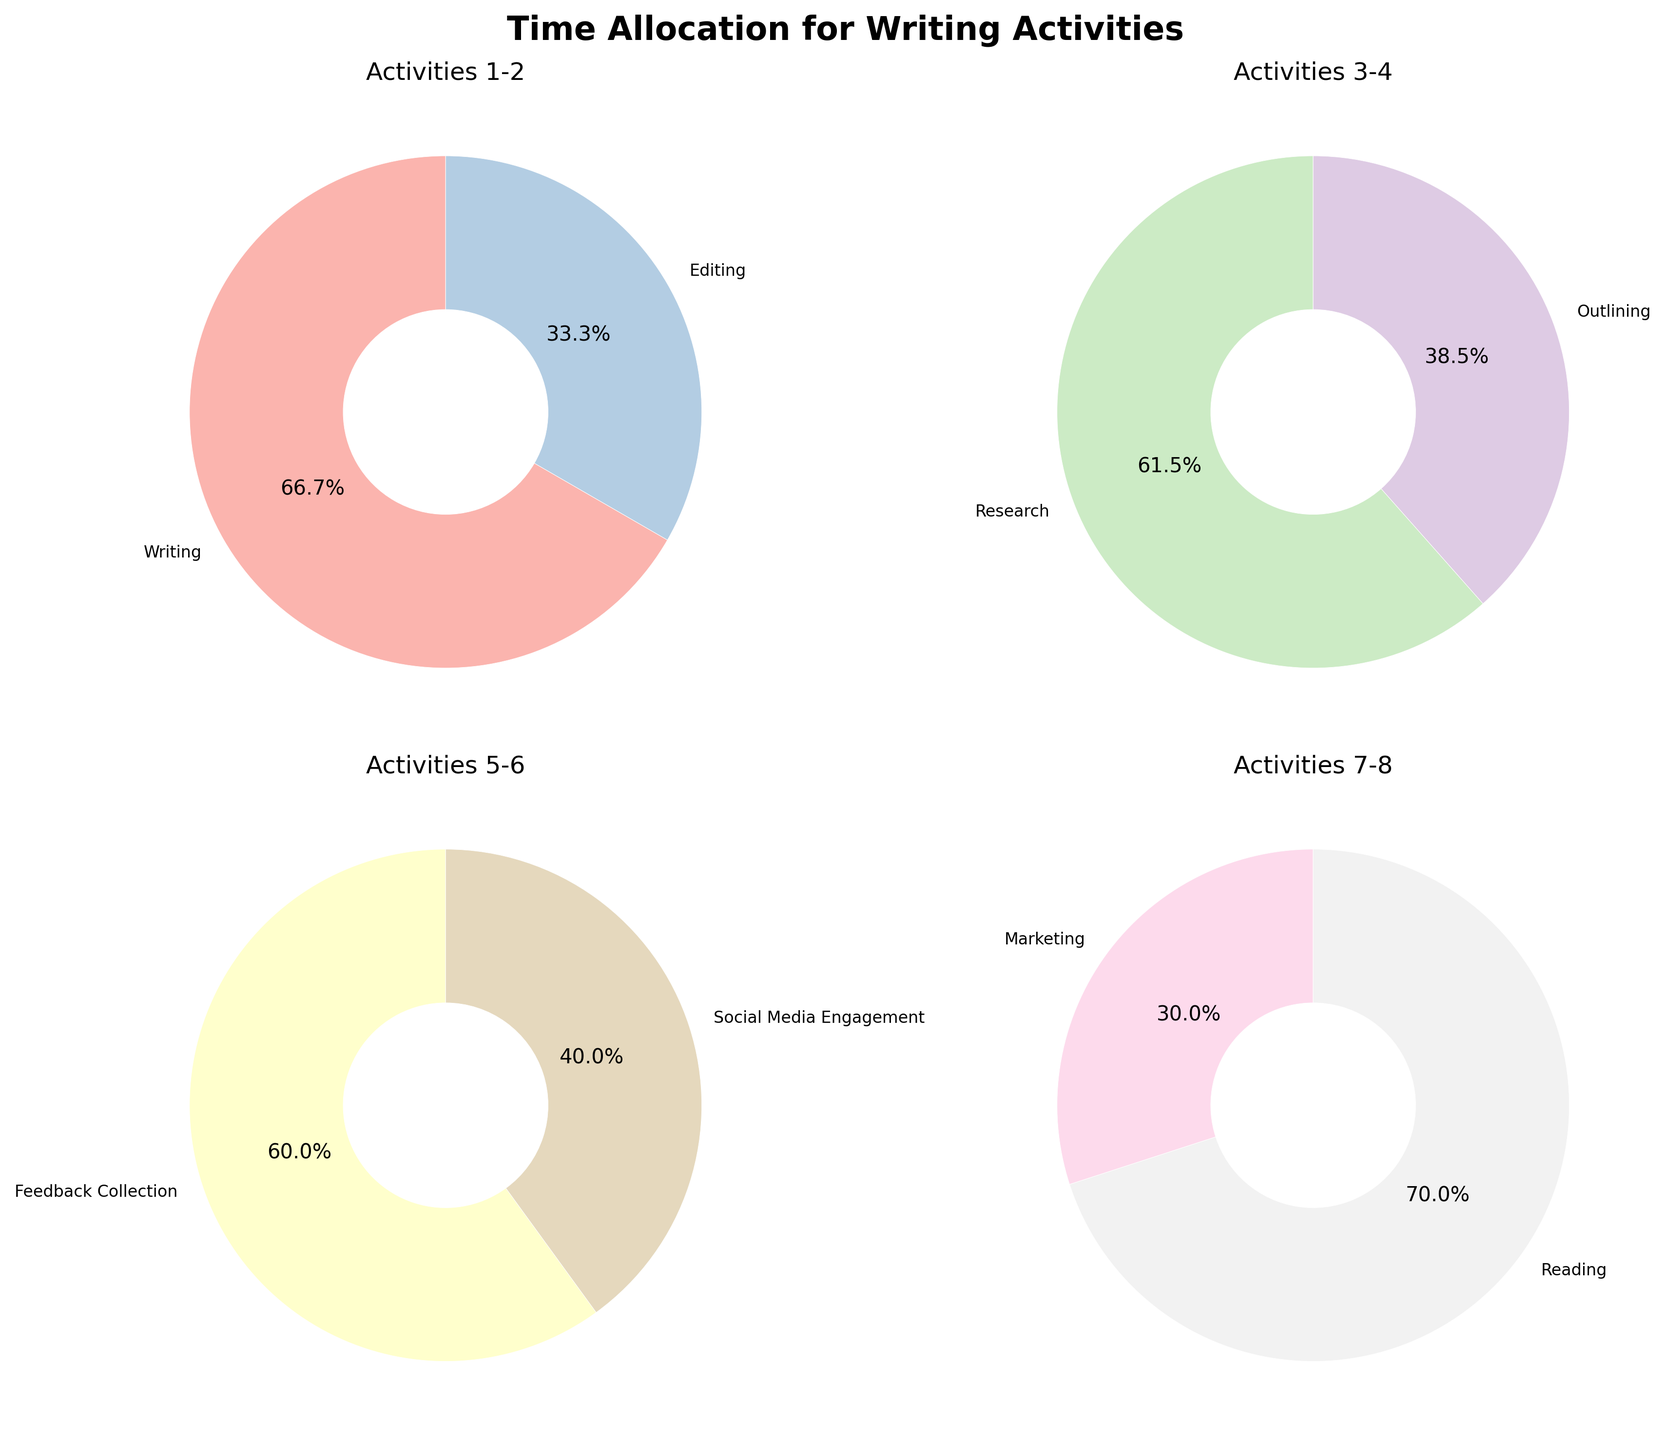How many pie charts are displayed in the figure? The figure consists of a 2x2 subplot layout, creating a total of 4 pie charts.
Answer: 4 What is the title of the figure? The title of the figure is placed above the subplots and reads "Time Allocation for Writing Activities".
Answer: Time Allocation for Writing Activities Which activities are represented in the first pie chart? The first pie chart corresponds to activities from the first subset, specifically "Writing" and "Editing".
Answer: Writing and Editing What percentage of time is allocated to "Research" compared to "Outlining"? In the second pie chart, the percentages for "Research" and "Outlining" are displayed. Research is allocated 8 hours and Outlining 5 hours. To find the percentage comparison, calculate `(8 / (8+5)) * 100` for Research and `(5 / (8+5)) * 100` for Outlining.
Answer: Research: 61.5%, Outlining: 38.5% Which activity has the lowest hour allocation in the figure? The activity "Marketing" shows only a 3-hour allocation, which is the smallest among all activities listed across the pie charts.
Answer: Marketing Are there any activities where time allocation is equal? By examining the pie charts, we see that no two activities have the same hours; each has a unique value.
Answer: No How is the time divided between Social Media Engagement and Marketing? The third pie chart shows these two activities. Sum the hours: Social Media Engagement has 4 hours and Marketing has 3 hours, totaling 7 hours.
Answer: 4 hours for Social Media Engagement, 3 hours for Marketing What activity appears in the last pie chart and takes the most time? Reviewing the final pie chart, "Reading" and "Feedback Collection" are present. Out of these, Reading with 7 hours takes more time than Feedback Collection with 6 hours.
Answer: Reading Compare the combined time spent on "Writing" and "Editing" with that on "Reading" and "Feedback Collection". Add the hours for each pair: Writing (20) + Editing (10) = 30, Reading (7) + Feedback Collection (6) = 13. Compare these sums to see that the combined time for Writing and Editing is higher.
Answer: Writing and Editing: 30 hours, Reading and Feedback Collection: 13 hours What is the average time spent on Social Media Engagement and Marketing? Sum the hours of Social Media Engagement (4) and Marketing (3) to get 7 hours. The average is `7 / 2 = 3.5`.
Answer: 3.5 hours 